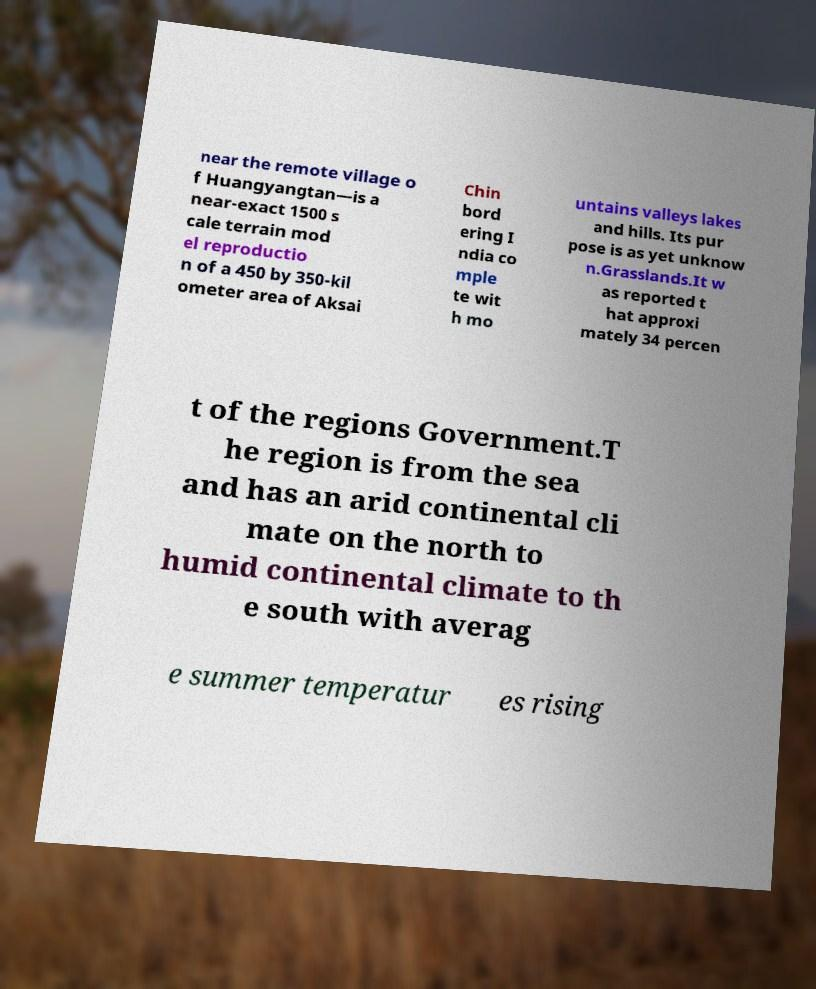Can you read and provide the text displayed in the image?This photo seems to have some interesting text. Can you extract and type it out for me? near the remote village o f Huangyangtan—is a near-exact 1500 s cale terrain mod el reproductio n of a 450 by 350-kil ometer area of Aksai Chin bord ering I ndia co mple te wit h mo untains valleys lakes and hills. Its pur pose is as yet unknow n.Grasslands.It w as reported t hat approxi mately 34 percen t of the regions Government.T he region is from the sea and has an arid continental cli mate on the north to humid continental climate to th e south with averag e summer temperatur es rising 